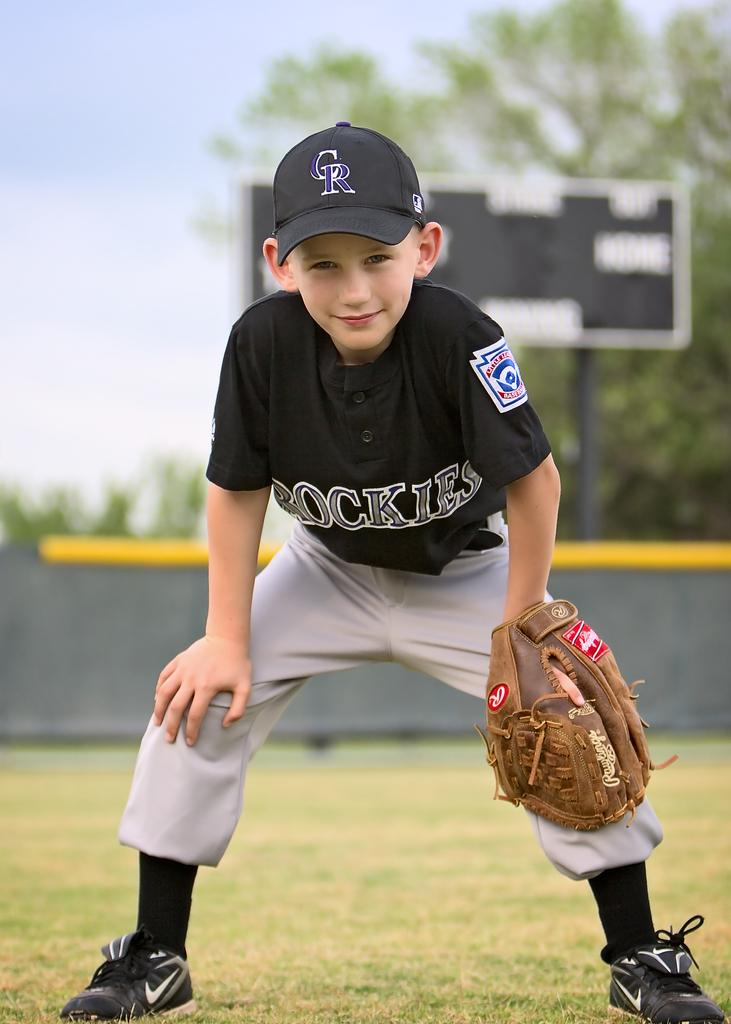Provide a one-sentence caption for the provided image. A young boy posing for a picture half crouched with the letters CR on his hat. 